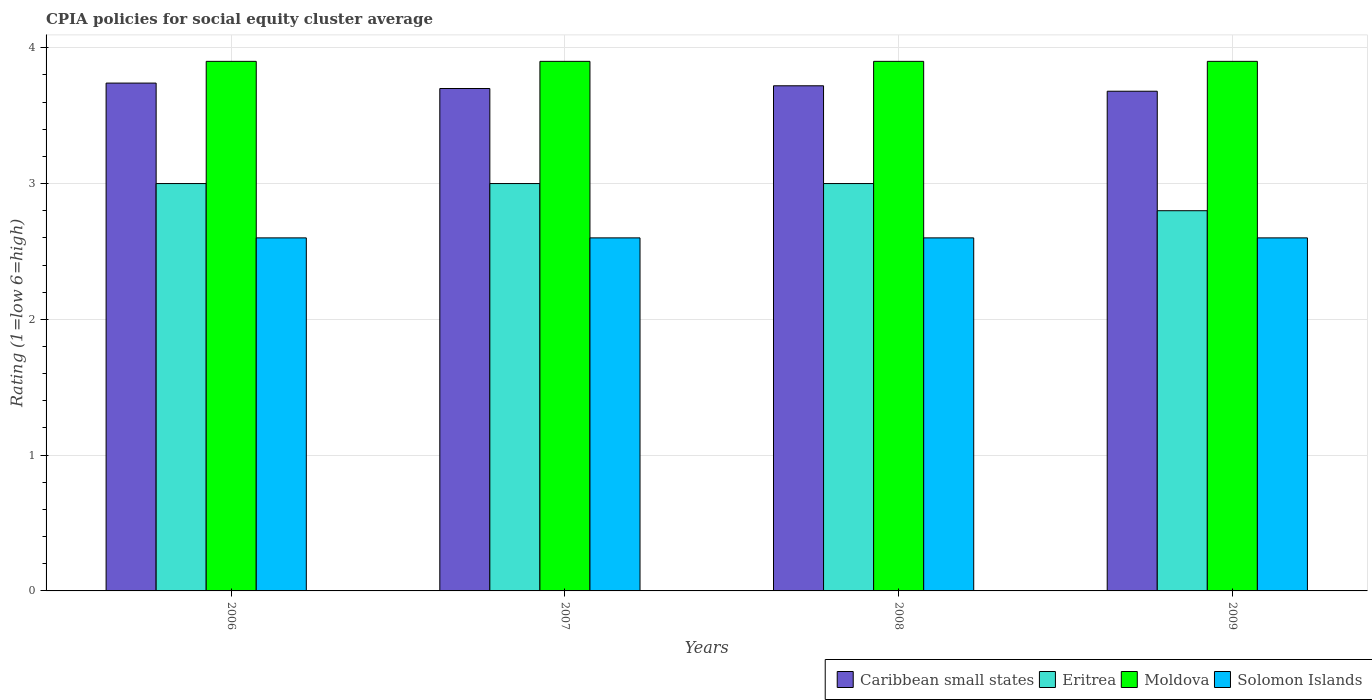How many different coloured bars are there?
Ensure brevity in your answer.  4. Are the number of bars per tick equal to the number of legend labels?
Keep it short and to the point. Yes. How many bars are there on the 3rd tick from the right?
Offer a terse response. 4. In how many cases, is the number of bars for a given year not equal to the number of legend labels?
Offer a very short reply. 0. What is the CPIA rating in Solomon Islands in 2007?
Provide a short and direct response. 2.6. What is the difference between the CPIA rating in Eritrea in 2008 and that in 2009?
Your answer should be compact. 0.2. What is the difference between the CPIA rating in Caribbean small states in 2008 and the CPIA rating in Solomon Islands in 2009?
Keep it short and to the point. 1.12. What is the average CPIA rating in Caribbean small states per year?
Ensure brevity in your answer.  3.71. In the year 2007, what is the difference between the CPIA rating in Solomon Islands and CPIA rating in Eritrea?
Your answer should be compact. -0.4. What is the ratio of the CPIA rating in Solomon Islands in 2006 to that in 2007?
Your answer should be very brief. 1. What is the difference between the highest and the second highest CPIA rating in Eritrea?
Offer a terse response. 0. What is the difference between the highest and the lowest CPIA rating in Caribbean small states?
Your answer should be compact. 0.06. In how many years, is the CPIA rating in Moldova greater than the average CPIA rating in Moldova taken over all years?
Offer a terse response. 0. What does the 1st bar from the left in 2007 represents?
Your answer should be very brief. Caribbean small states. What does the 3rd bar from the right in 2009 represents?
Offer a terse response. Eritrea. Are all the bars in the graph horizontal?
Ensure brevity in your answer.  No. What is the difference between two consecutive major ticks on the Y-axis?
Provide a short and direct response. 1. Are the values on the major ticks of Y-axis written in scientific E-notation?
Provide a succinct answer. No. Does the graph contain grids?
Keep it short and to the point. Yes. Where does the legend appear in the graph?
Provide a succinct answer. Bottom right. What is the title of the graph?
Provide a short and direct response. CPIA policies for social equity cluster average. Does "Jamaica" appear as one of the legend labels in the graph?
Keep it short and to the point. No. What is the Rating (1=low 6=high) of Caribbean small states in 2006?
Your response must be concise. 3.74. What is the Rating (1=low 6=high) in Moldova in 2006?
Offer a terse response. 3.9. What is the Rating (1=low 6=high) of Caribbean small states in 2007?
Your answer should be very brief. 3.7. What is the Rating (1=low 6=high) in Eritrea in 2007?
Provide a succinct answer. 3. What is the Rating (1=low 6=high) in Moldova in 2007?
Ensure brevity in your answer.  3.9. What is the Rating (1=low 6=high) in Solomon Islands in 2007?
Provide a short and direct response. 2.6. What is the Rating (1=low 6=high) of Caribbean small states in 2008?
Your response must be concise. 3.72. What is the Rating (1=low 6=high) of Moldova in 2008?
Give a very brief answer. 3.9. What is the Rating (1=low 6=high) of Caribbean small states in 2009?
Keep it short and to the point. 3.68. What is the Rating (1=low 6=high) in Eritrea in 2009?
Your response must be concise. 2.8. What is the Rating (1=low 6=high) of Moldova in 2009?
Offer a very short reply. 3.9. What is the Rating (1=low 6=high) of Solomon Islands in 2009?
Provide a short and direct response. 2.6. Across all years, what is the maximum Rating (1=low 6=high) of Caribbean small states?
Ensure brevity in your answer.  3.74. Across all years, what is the maximum Rating (1=low 6=high) of Eritrea?
Your answer should be compact. 3. Across all years, what is the minimum Rating (1=low 6=high) of Caribbean small states?
Provide a short and direct response. 3.68. Across all years, what is the minimum Rating (1=low 6=high) of Eritrea?
Make the answer very short. 2.8. Across all years, what is the minimum Rating (1=low 6=high) of Solomon Islands?
Make the answer very short. 2.6. What is the total Rating (1=low 6=high) in Caribbean small states in the graph?
Provide a short and direct response. 14.84. What is the total Rating (1=low 6=high) of Eritrea in the graph?
Your answer should be very brief. 11.8. What is the difference between the Rating (1=low 6=high) of Solomon Islands in 2006 and that in 2007?
Provide a short and direct response. 0. What is the difference between the Rating (1=low 6=high) in Moldova in 2006 and that in 2008?
Keep it short and to the point. 0. What is the difference between the Rating (1=low 6=high) of Eritrea in 2006 and that in 2009?
Provide a short and direct response. 0.2. What is the difference between the Rating (1=low 6=high) of Caribbean small states in 2007 and that in 2008?
Keep it short and to the point. -0.02. What is the difference between the Rating (1=low 6=high) in Solomon Islands in 2007 and that in 2008?
Offer a terse response. 0. What is the difference between the Rating (1=low 6=high) in Eritrea in 2007 and that in 2009?
Your answer should be very brief. 0.2. What is the difference between the Rating (1=low 6=high) of Caribbean small states in 2008 and that in 2009?
Your response must be concise. 0.04. What is the difference between the Rating (1=low 6=high) of Eritrea in 2008 and that in 2009?
Keep it short and to the point. 0.2. What is the difference between the Rating (1=low 6=high) in Moldova in 2008 and that in 2009?
Give a very brief answer. 0. What is the difference between the Rating (1=low 6=high) in Solomon Islands in 2008 and that in 2009?
Provide a short and direct response. 0. What is the difference between the Rating (1=low 6=high) of Caribbean small states in 2006 and the Rating (1=low 6=high) of Eritrea in 2007?
Give a very brief answer. 0.74. What is the difference between the Rating (1=low 6=high) in Caribbean small states in 2006 and the Rating (1=low 6=high) in Moldova in 2007?
Provide a succinct answer. -0.16. What is the difference between the Rating (1=low 6=high) of Caribbean small states in 2006 and the Rating (1=low 6=high) of Solomon Islands in 2007?
Your response must be concise. 1.14. What is the difference between the Rating (1=low 6=high) in Eritrea in 2006 and the Rating (1=low 6=high) in Moldova in 2007?
Give a very brief answer. -0.9. What is the difference between the Rating (1=low 6=high) of Moldova in 2006 and the Rating (1=low 6=high) of Solomon Islands in 2007?
Provide a succinct answer. 1.3. What is the difference between the Rating (1=low 6=high) in Caribbean small states in 2006 and the Rating (1=low 6=high) in Eritrea in 2008?
Offer a terse response. 0.74. What is the difference between the Rating (1=low 6=high) of Caribbean small states in 2006 and the Rating (1=low 6=high) of Moldova in 2008?
Your answer should be very brief. -0.16. What is the difference between the Rating (1=low 6=high) of Caribbean small states in 2006 and the Rating (1=low 6=high) of Solomon Islands in 2008?
Provide a succinct answer. 1.14. What is the difference between the Rating (1=low 6=high) of Eritrea in 2006 and the Rating (1=low 6=high) of Moldova in 2008?
Make the answer very short. -0.9. What is the difference between the Rating (1=low 6=high) in Eritrea in 2006 and the Rating (1=low 6=high) in Solomon Islands in 2008?
Keep it short and to the point. 0.4. What is the difference between the Rating (1=low 6=high) in Caribbean small states in 2006 and the Rating (1=low 6=high) in Eritrea in 2009?
Your answer should be compact. 0.94. What is the difference between the Rating (1=low 6=high) of Caribbean small states in 2006 and the Rating (1=low 6=high) of Moldova in 2009?
Offer a very short reply. -0.16. What is the difference between the Rating (1=low 6=high) of Caribbean small states in 2006 and the Rating (1=low 6=high) of Solomon Islands in 2009?
Your answer should be compact. 1.14. What is the difference between the Rating (1=low 6=high) of Caribbean small states in 2007 and the Rating (1=low 6=high) of Eritrea in 2008?
Keep it short and to the point. 0.7. What is the difference between the Rating (1=low 6=high) in Caribbean small states in 2007 and the Rating (1=low 6=high) in Solomon Islands in 2008?
Offer a terse response. 1.1. What is the difference between the Rating (1=low 6=high) in Eritrea in 2007 and the Rating (1=low 6=high) in Solomon Islands in 2008?
Provide a short and direct response. 0.4. What is the difference between the Rating (1=low 6=high) in Moldova in 2007 and the Rating (1=low 6=high) in Solomon Islands in 2008?
Ensure brevity in your answer.  1.3. What is the difference between the Rating (1=low 6=high) in Caribbean small states in 2007 and the Rating (1=low 6=high) in Eritrea in 2009?
Your answer should be compact. 0.9. What is the difference between the Rating (1=low 6=high) in Caribbean small states in 2007 and the Rating (1=low 6=high) in Moldova in 2009?
Provide a short and direct response. -0.2. What is the difference between the Rating (1=low 6=high) in Caribbean small states in 2007 and the Rating (1=low 6=high) in Solomon Islands in 2009?
Your response must be concise. 1.1. What is the difference between the Rating (1=low 6=high) in Eritrea in 2007 and the Rating (1=low 6=high) in Moldova in 2009?
Make the answer very short. -0.9. What is the difference between the Rating (1=low 6=high) in Caribbean small states in 2008 and the Rating (1=low 6=high) in Moldova in 2009?
Keep it short and to the point. -0.18. What is the difference between the Rating (1=low 6=high) of Caribbean small states in 2008 and the Rating (1=low 6=high) of Solomon Islands in 2009?
Provide a short and direct response. 1.12. What is the difference between the Rating (1=low 6=high) of Eritrea in 2008 and the Rating (1=low 6=high) of Moldova in 2009?
Provide a succinct answer. -0.9. What is the difference between the Rating (1=low 6=high) in Eritrea in 2008 and the Rating (1=low 6=high) in Solomon Islands in 2009?
Provide a succinct answer. 0.4. What is the average Rating (1=low 6=high) of Caribbean small states per year?
Make the answer very short. 3.71. What is the average Rating (1=low 6=high) of Eritrea per year?
Provide a succinct answer. 2.95. In the year 2006, what is the difference between the Rating (1=low 6=high) of Caribbean small states and Rating (1=low 6=high) of Eritrea?
Provide a short and direct response. 0.74. In the year 2006, what is the difference between the Rating (1=low 6=high) in Caribbean small states and Rating (1=low 6=high) in Moldova?
Keep it short and to the point. -0.16. In the year 2006, what is the difference between the Rating (1=low 6=high) of Caribbean small states and Rating (1=low 6=high) of Solomon Islands?
Keep it short and to the point. 1.14. In the year 2006, what is the difference between the Rating (1=low 6=high) in Moldova and Rating (1=low 6=high) in Solomon Islands?
Offer a terse response. 1.3. In the year 2007, what is the difference between the Rating (1=low 6=high) of Eritrea and Rating (1=low 6=high) of Moldova?
Ensure brevity in your answer.  -0.9. In the year 2007, what is the difference between the Rating (1=low 6=high) in Eritrea and Rating (1=low 6=high) in Solomon Islands?
Give a very brief answer. 0.4. In the year 2008, what is the difference between the Rating (1=low 6=high) in Caribbean small states and Rating (1=low 6=high) in Eritrea?
Offer a very short reply. 0.72. In the year 2008, what is the difference between the Rating (1=low 6=high) in Caribbean small states and Rating (1=low 6=high) in Moldova?
Your answer should be very brief. -0.18. In the year 2008, what is the difference between the Rating (1=low 6=high) in Caribbean small states and Rating (1=low 6=high) in Solomon Islands?
Ensure brevity in your answer.  1.12. In the year 2009, what is the difference between the Rating (1=low 6=high) in Caribbean small states and Rating (1=low 6=high) in Moldova?
Offer a very short reply. -0.22. In the year 2009, what is the difference between the Rating (1=low 6=high) in Caribbean small states and Rating (1=low 6=high) in Solomon Islands?
Provide a succinct answer. 1.08. In the year 2009, what is the difference between the Rating (1=low 6=high) in Eritrea and Rating (1=low 6=high) in Solomon Islands?
Offer a very short reply. 0.2. In the year 2009, what is the difference between the Rating (1=low 6=high) of Moldova and Rating (1=low 6=high) of Solomon Islands?
Offer a terse response. 1.3. What is the ratio of the Rating (1=low 6=high) in Caribbean small states in 2006 to that in 2007?
Provide a succinct answer. 1.01. What is the ratio of the Rating (1=low 6=high) in Eritrea in 2006 to that in 2007?
Provide a succinct answer. 1. What is the ratio of the Rating (1=low 6=high) of Caribbean small states in 2006 to that in 2008?
Offer a terse response. 1.01. What is the ratio of the Rating (1=low 6=high) of Solomon Islands in 2006 to that in 2008?
Your answer should be compact. 1. What is the ratio of the Rating (1=low 6=high) of Caribbean small states in 2006 to that in 2009?
Your answer should be very brief. 1.02. What is the ratio of the Rating (1=low 6=high) in Eritrea in 2006 to that in 2009?
Provide a succinct answer. 1.07. What is the ratio of the Rating (1=low 6=high) in Moldova in 2006 to that in 2009?
Give a very brief answer. 1. What is the ratio of the Rating (1=low 6=high) of Solomon Islands in 2006 to that in 2009?
Your response must be concise. 1. What is the ratio of the Rating (1=low 6=high) in Solomon Islands in 2007 to that in 2008?
Ensure brevity in your answer.  1. What is the ratio of the Rating (1=low 6=high) in Caribbean small states in 2007 to that in 2009?
Give a very brief answer. 1.01. What is the ratio of the Rating (1=low 6=high) in Eritrea in 2007 to that in 2009?
Give a very brief answer. 1.07. What is the ratio of the Rating (1=low 6=high) of Moldova in 2007 to that in 2009?
Your response must be concise. 1. What is the ratio of the Rating (1=low 6=high) of Caribbean small states in 2008 to that in 2009?
Provide a short and direct response. 1.01. What is the ratio of the Rating (1=low 6=high) in Eritrea in 2008 to that in 2009?
Your answer should be compact. 1.07. What is the ratio of the Rating (1=low 6=high) in Moldova in 2008 to that in 2009?
Your answer should be compact. 1. What is the difference between the highest and the second highest Rating (1=low 6=high) in Eritrea?
Your answer should be very brief. 0. What is the difference between the highest and the second highest Rating (1=low 6=high) of Moldova?
Offer a terse response. 0. What is the difference between the highest and the second highest Rating (1=low 6=high) of Solomon Islands?
Your answer should be very brief. 0. What is the difference between the highest and the lowest Rating (1=low 6=high) in Caribbean small states?
Offer a terse response. 0.06. What is the difference between the highest and the lowest Rating (1=low 6=high) in Eritrea?
Your answer should be compact. 0.2. What is the difference between the highest and the lowest Rating (1=low 6=high) in Solomon Islands?
Ensure brevity in your answer.  0. 